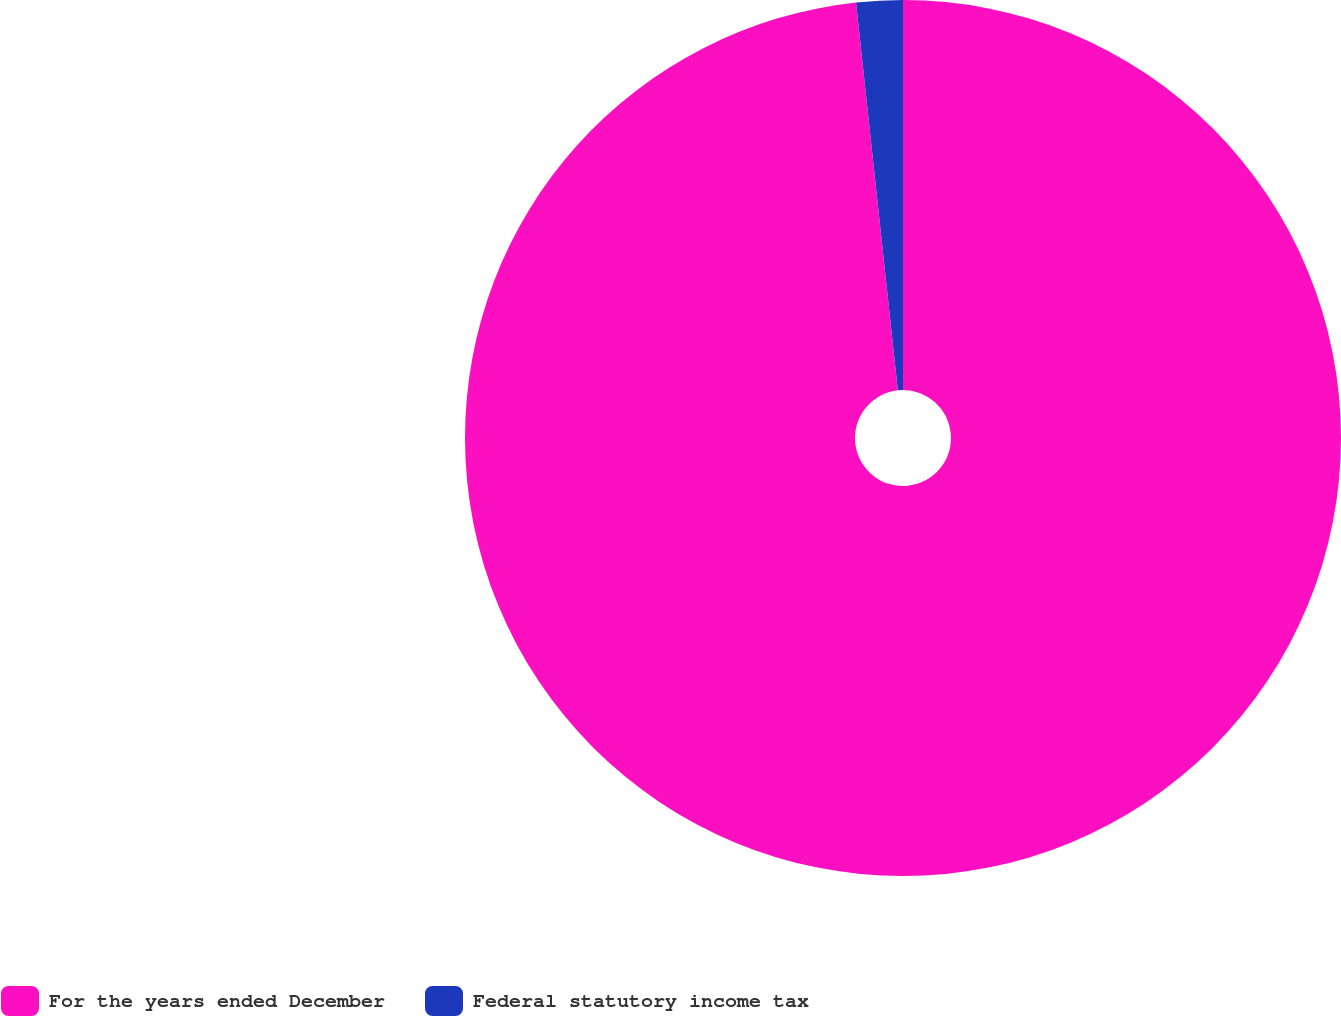Convert chart. <chart><loc_0><loc_0><loc_500><loc_500><pie_chart><fcel>For the years ended December<fcel>Federal statutory income tax<nl><fcel>98.29%<fcel>1.71%<nl></chart> 